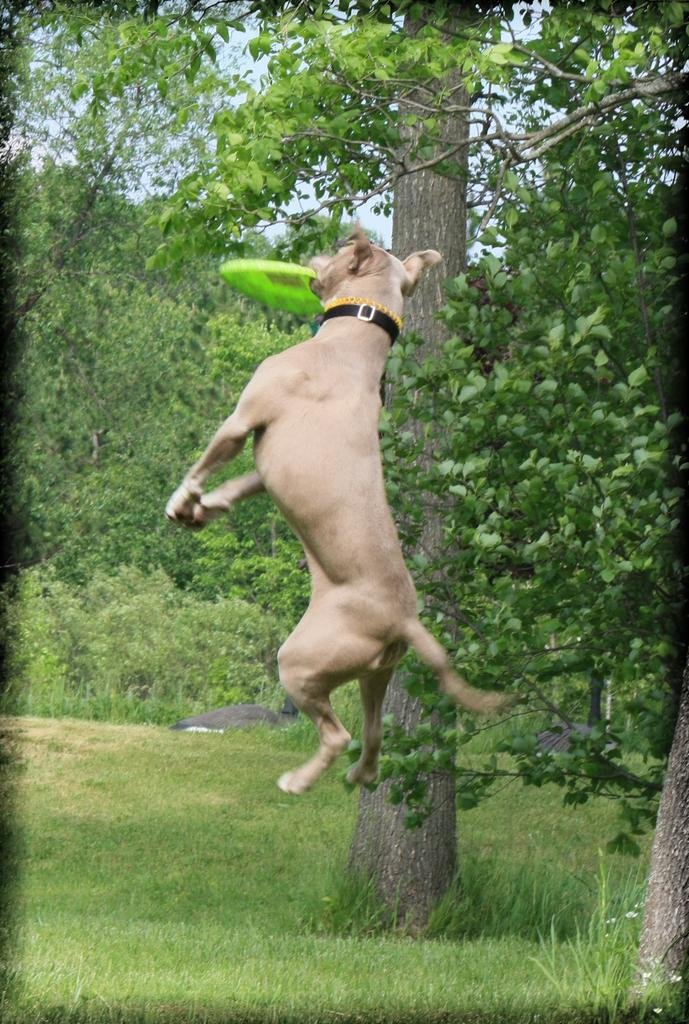What type of animal is in the image? There is a dog in the image. What is the dog doing in the image? The dog is holding a disc in its mouth. What can be seen in the background of the image? There is grass, trees, and the sky visible in the background of the image. Where was the image taken? The image was taken in a park. When was the image taken? The image was taken during the day. How many bikes are visible in the image? There are no bikes visible in the image; it features a dog holding a disc in its mouth. What type of top is the dog wearing in the image? The dog is not wearing a top in the image; it is a dog. 